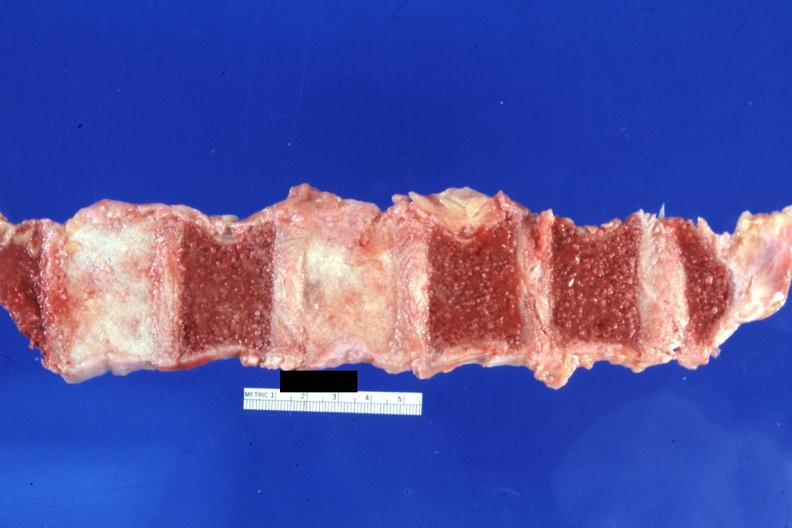does this image show cut surface typical ivory vertebra do not have history at this time diagnosis assumed?
Answer the question using a single word or phrase. Yes 